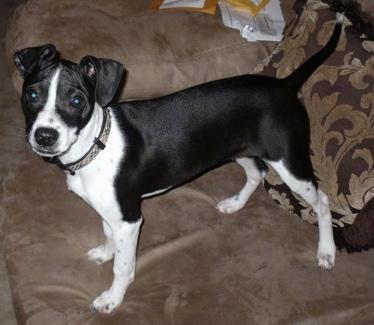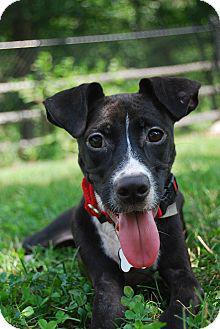The first image is the image on the left, the second image is the image on the right. Considering the images on both sides, is "The dog on the left wears a collar and stands on all fours, and the dog on the right is in a grassy spot and has black-and-white coloring." valid? Answer yes or no. Yes. The first image is the image on the left, the second image is the image on the right. For the images shown, is this caption "The dog in the image on the right is sitting in the grass outside." true? Answer yes or no. Yes. 